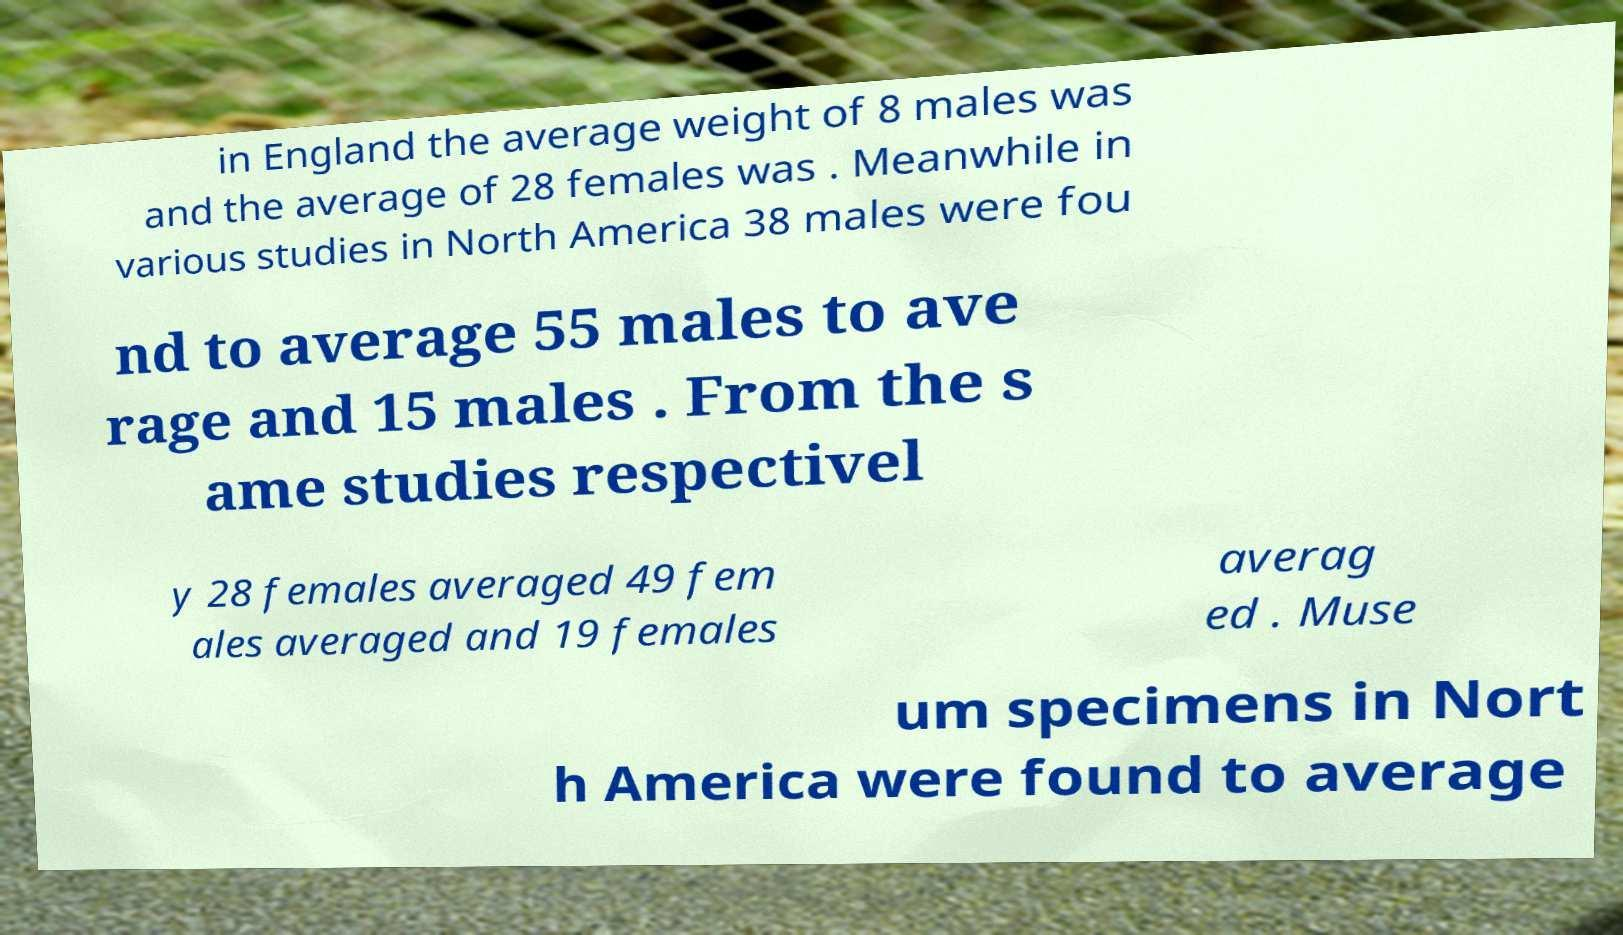What messages or text are displayed in this image? I need them in a readable, typed format. in England the average weight of 8 males was and the average of 28 females was . Meanwhile in various studies in North America 38 males were fou nd to average 55 males to ave rage and 15 males . From the s ame studies respectivel y 28 females averaged 49 fem ales averaged and 19 females averag ed . Muse um specimens in Nort h America were found to average 